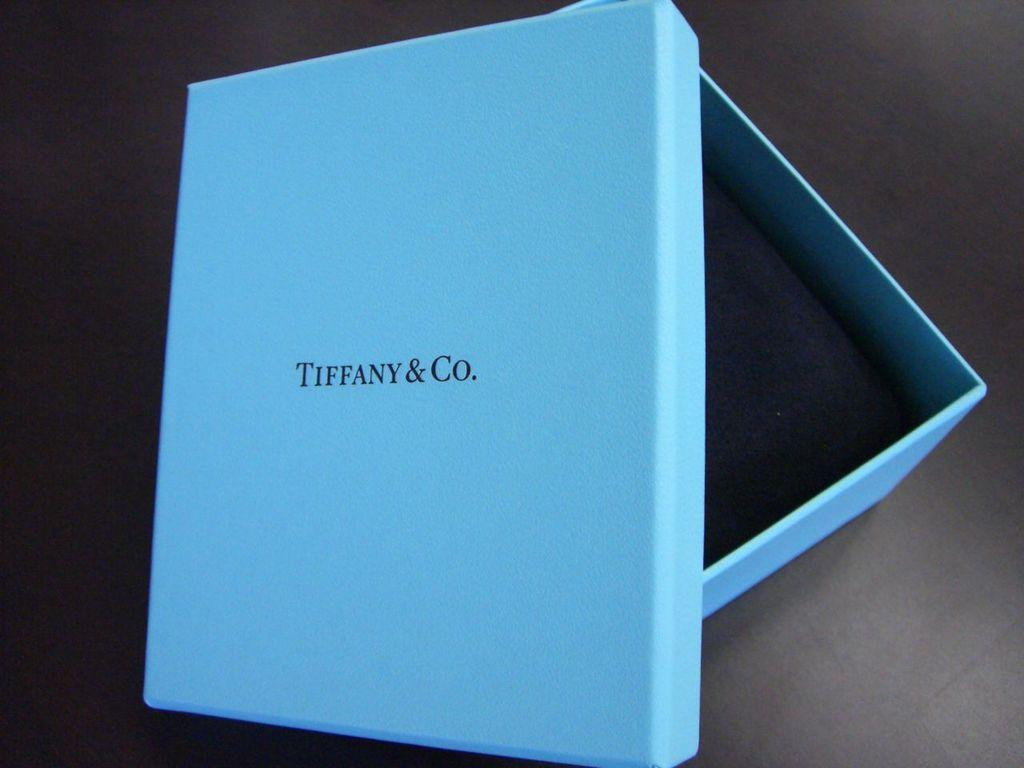What jewerly company is this box from?
Keep it short and to the point. Tiffany & co. 